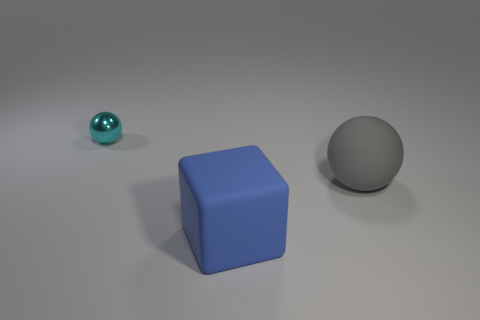Is there any other thing that is the same size as the cyan metal sphere?
Give a very brief answer. No. There is a object that is both on the right side of the cyan metallic sphere and left of the gray thing; what material is it made of?
Offer a very short reply. Rubber. How many tiny blue objects have the same shape as the big gray object?
Offer a terse response. 0. There is a ball in front of the metallic sphere; what is it made of?
Your answer should be very brief. Rubber. Are there fewer small spheres that are in front of the tiny cyan metal sphere than big purple matte cubes?
Offer a terse response. No. Is the big gray object the same shape as the large blue object?
Ensure brevity in your answer.  No. Is there any other thing that has the same shape as the big blue matte thing?
Your answer should be compact. No. Are there any things?
Offer a very short reply. Yes. There is a small metallic object; does it have the same shape as the rubber object behind the blue cube?
Provide a succinct answer. Yes. What is the object left of the large thing on the left side of the large gray matte ball made of?
Provide a short and direct response. Metal. 